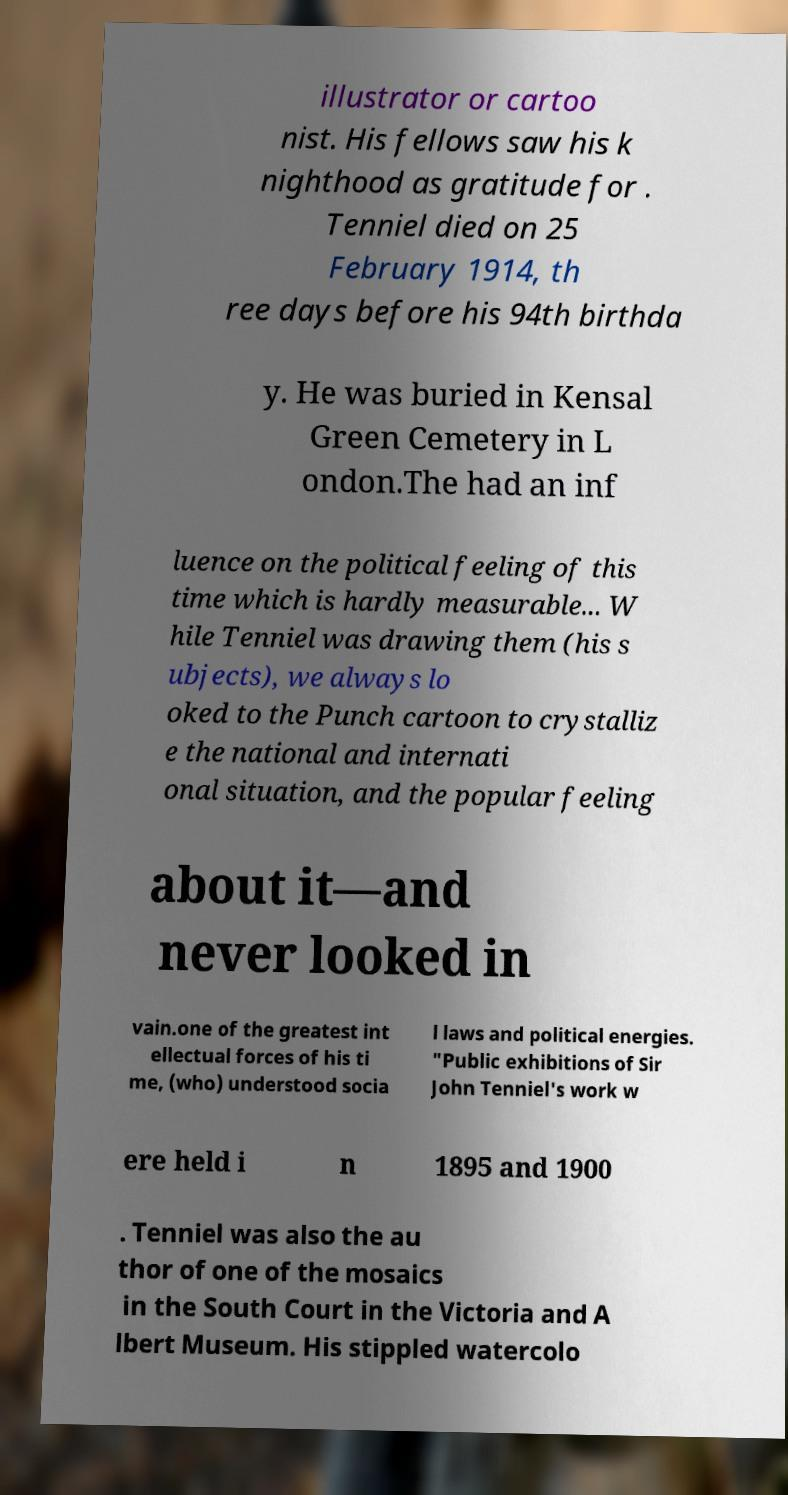I need the written content from this picture converted into text. Can you do that? illustrator or cartoo nist. His fellows saw his k nighthood as gratitude for . Tenniel died on 25 February 1914, th ree days before his 94th birthda y. He was buried in Kensal Green Cemetery in L ondon.The had an inf luence on the political feeling of this time which is hardly measurable... W hile Tenniel was drawing them (his s ubjects), we always lo oked to the Punch cartoon to crystalliz e the national and internati onal situation, and the popular feeling about it—and never looked in vain.one of the greatest int ellectual forces of his ti me, (who) understood socia l laws and political energies. "Public exhibitions of Sir John Tenniel's work w ere held i n 1895 and 1900 . Tenniel was also the au thor of one of the mosaics in the South Court in the Victoria and A lbert Museum. His stippled watercolo 